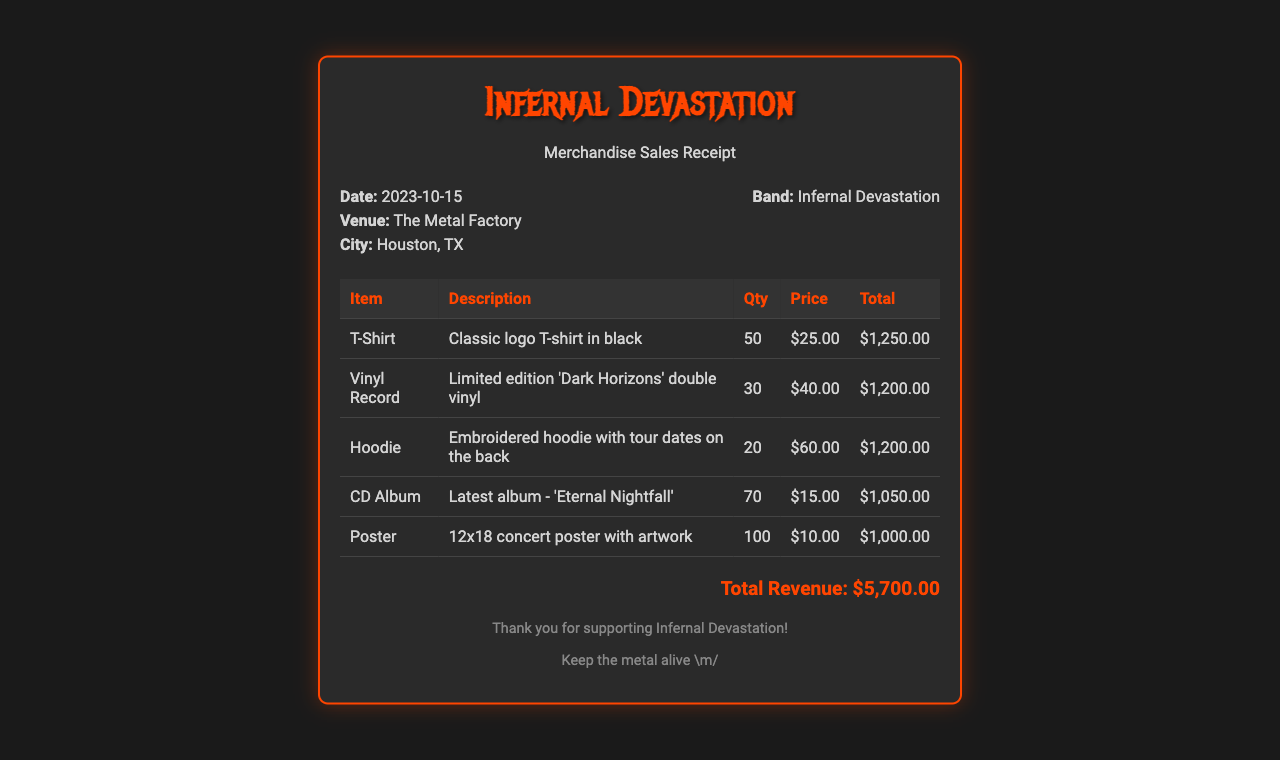What is the date of the merch sale? The date is listed in the receipt under the date section, which is important for tracking purposes.
Answer: 2023-10-15 Where was the event held? The venue is mentioned in the document, which indicates where the merchandise sale took place.
Answer: The Metal Factory How many T-Shirts were sold? The quantity of T-Shirts sold is specified in the table, illustrating the popularity of this item.
Answer: 50 What is the price of a Vinyl Record? The price is provided in the table, which is crucial for knowing how much customers paid for this item.
Answer: $40.00 What is the total revenue generated from merchandise sales? The total revenue is calculated from all items sold, presented at the bottom of the receipt, summarizing financial success.
Answer: $5,700.00 How many items make up the merchandise list? The number of different items sold is found by counting the rows in the table, giving an overview of merchandise variety.
Answer: 5 Which item had the highest total sales revenue? Analyzing the total column in the table identifies which item generated the most income for the band.
Answer: T-Shirt What does the merchandise receipt thank customers for? The footer expresses gratitude towards customers for their support, reflecting the band's appreciation.
Answer: Supporting Infernal Devastation What artwork is featured on the Poster? The description of the poster in the table indicates it features concert artwork, giving fans a visual representation of the event.
Answer: Artwork 